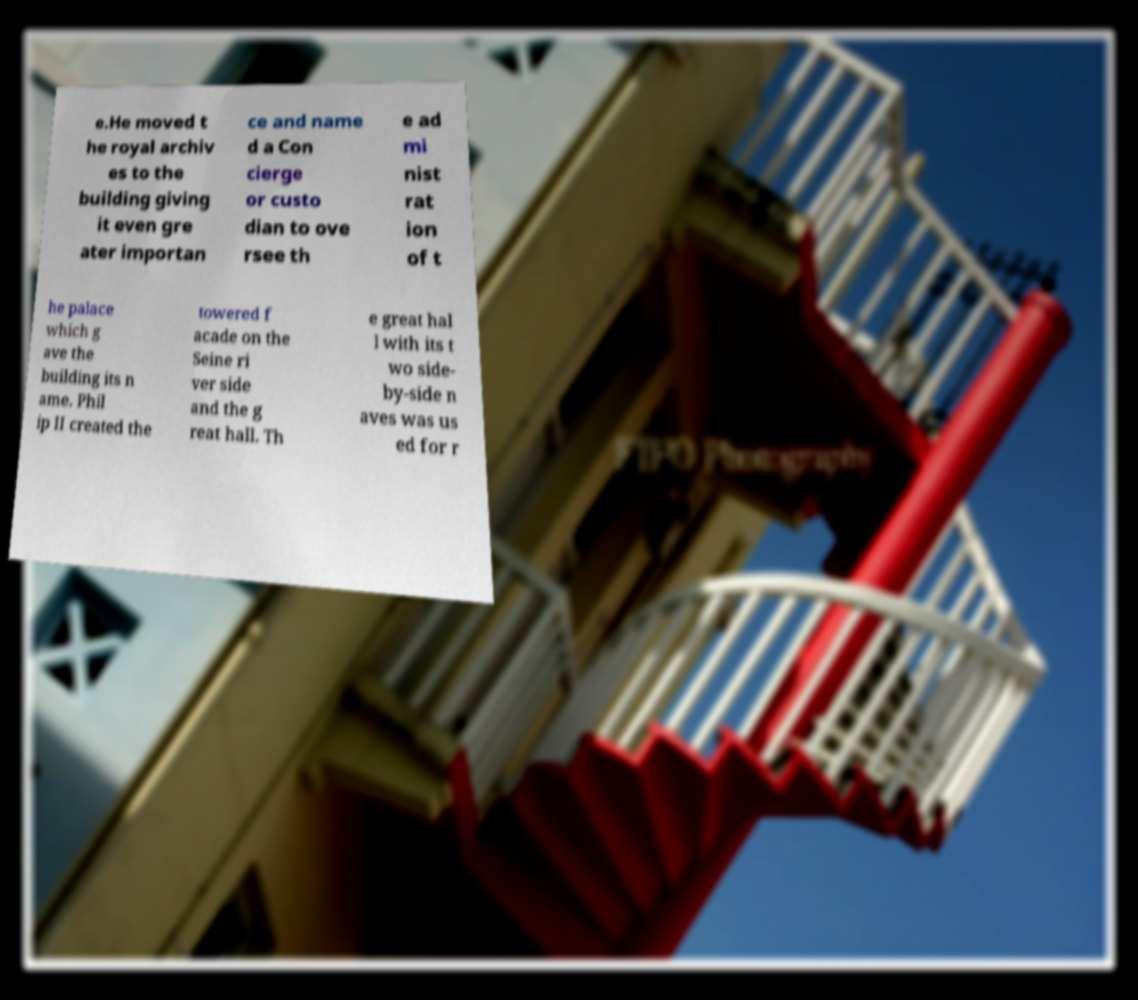What messages or text are displayed in this image? I need them in a readable, typed format. e.He moved t he royal archiv es to the building giving it even gre ater importan ce and name d a Con cierge or custo dian to ove rsee th e ad mi nist rat ion of t he palace which g ave the building its n ame. Phil ip II created the towered f acade on the Seine ri ver side and the g reat hall. Th e great hal l with its t wo side- by-side n aves was us ed for r 